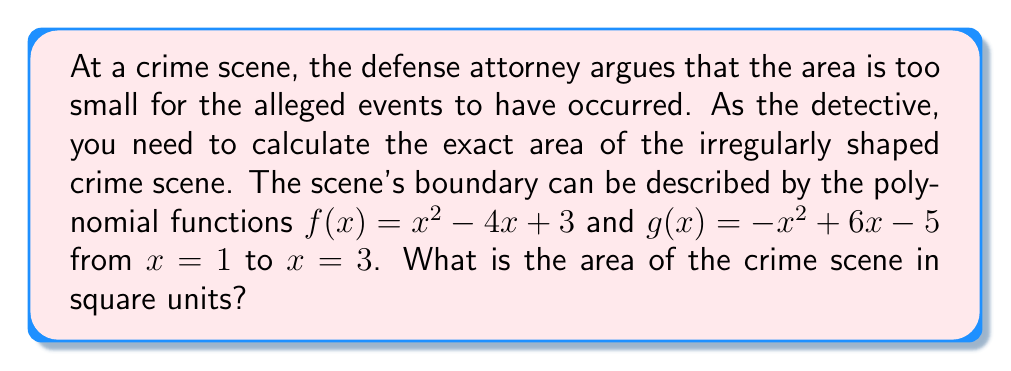What is the answer to this math problem? To calculate the area between two polynomial functions, we need to:

1. Find the difference between the upper and lower functions:
   $h(x) = g(x) - f(x) = (-x^2+6x-5) - (x^2-4x+3) = -2x^2+10x-8$

2. Integrate this difference over the given interval:
   $$A = \int_1^3 h(x) dx = \int_1^3 (-2x^2+10x-8) dx$$

3. Solve the integral:
   $$A = \left[-\frac{2}{3}x^3 + 5x^2 - 8x\right]_1^3$$

4. Evaluate the integral:
   $$A = \left[-\frac{2}{3}(3^3) + 5(3^2) - 8(3)\right] - \left[-\frac{2}{3}(1^3) + 5(1^2) - 8(1)\right]$$
   $$A = \left[-18 + 45 - 24\right] - \left[-\frac{2}{3} + 5 - 8\right]$$
   $$A = 3 - \left(-\frac{11}{3}\right) = 3 + \frac{11}{3} = \frac{20}{3}$$

5. The area is $\frac{20}{3}$ square units.
Answer: $\frac{20}{3}$ square units 